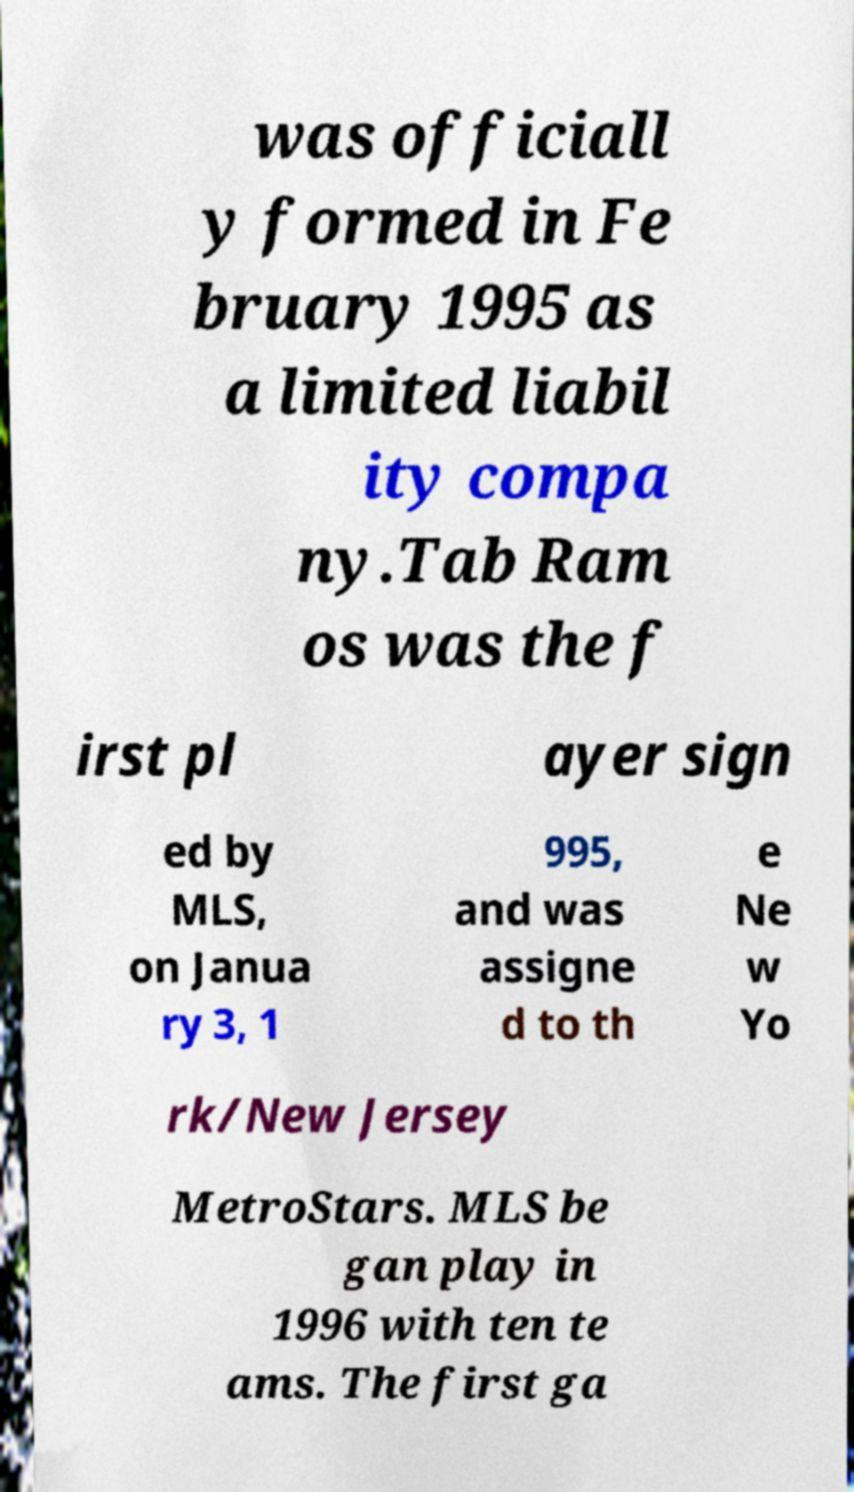Please identify and transcribe the text found in this image. was officiall y formed in Fe bruary 1995 as a limited liabil ity compa ny.Tab Ram os was the f irst pl ayer sign ed by MLS, on Janua ry 3, 1 995, and was assigne d to th e Ne w Yo rk/New Jersey MetroStars. MLS be gan play in 1996 with ten te ams. The first ga 